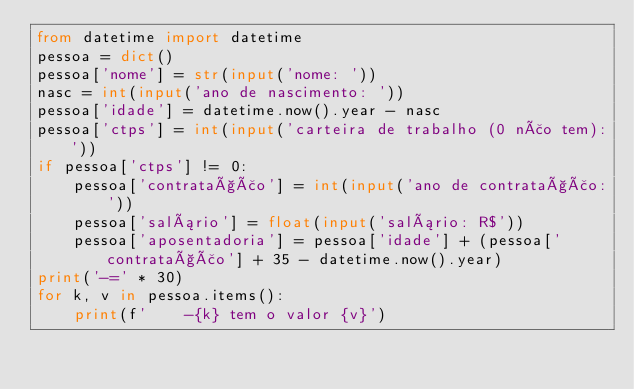<code> <loc_0><loc_0><loc_500><loc_500><_Python_>from datetime import datetime
pessoa = dict()
pessoa['nome'] = str(input('nome: '))
nasc = int(input('ano de nascimento: '))
pessoa['idade'] = datetime.now().year - nasc
pessoa['ctps'] = int(input('carteira de trabalho (0 não tem):'))
if pessoa['ctps'] != 0:
    pessoa['contratação'] = int(input('ano de contratação:'))
    pessoa['salário'] = float(input('salário: R$'))
    pessoa['aposentadoria'] = pessoa['idade'] + (pessoa['contratação'] + 35 - datetime.now().year)
print('-=' * 30)
for k, v in pessoa.items():
    print(f'    -{k} tem o valor {v}')</code> 